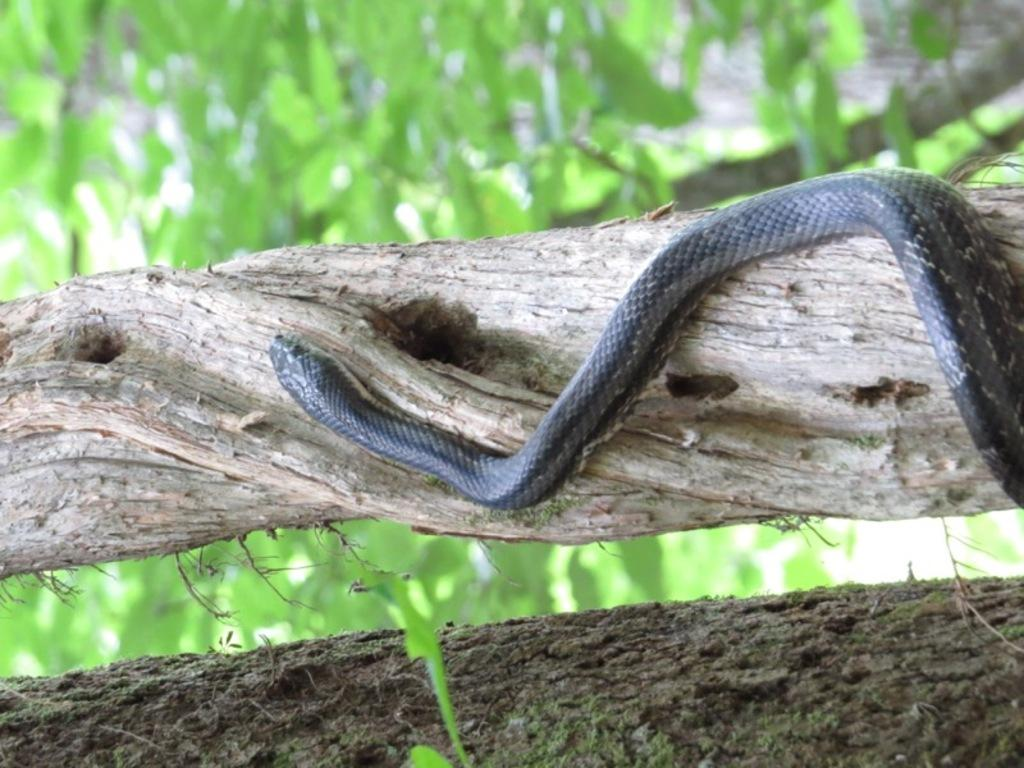What animal can be seen in the image? There is a snake in the image. What is the snake doing in the image? The snake is crawling on the trunk surface of a tree. What can be seen in the background of the image? There are trees in the background of the image. What type of curtain is hanging from the snake's tail in the image? There is no curtain present in the image, and the snake's tail is not mentioned as having any attachment. 